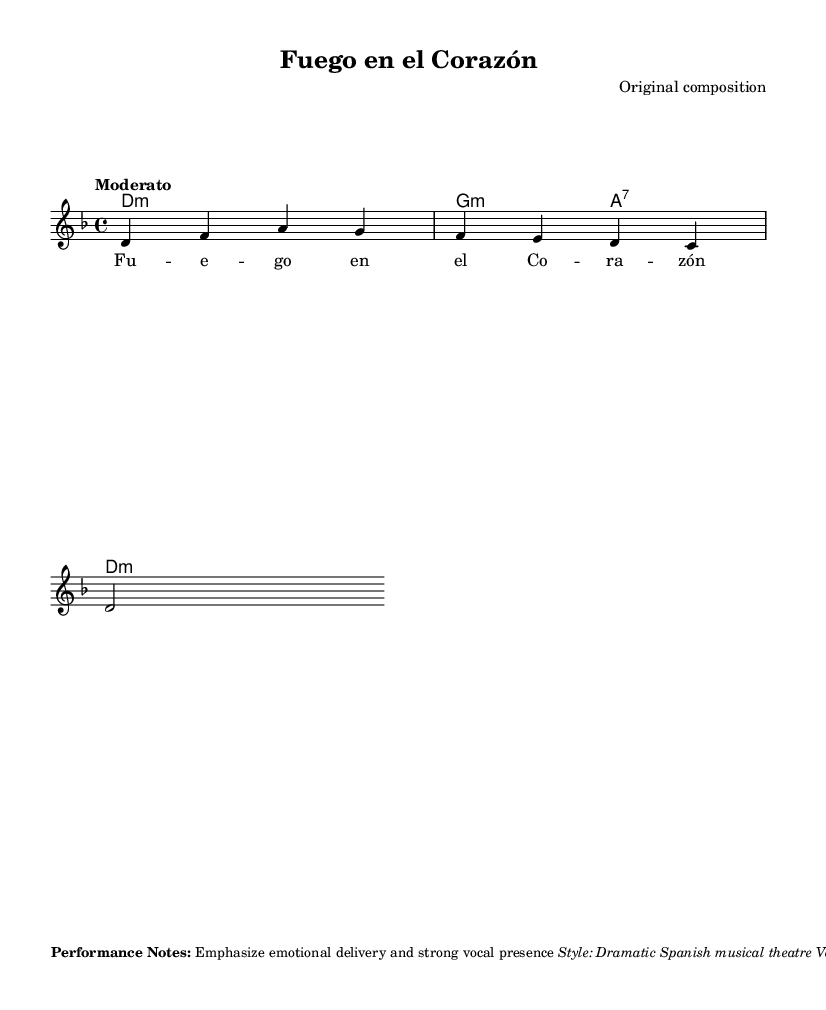What is the key signature of this music? The key signature is D minor, indicated by one flat (B flat) in the score.
Answer: D minor What is the time signature of this music? The time signature is 4/4, which means there are four beats in each measure, as shown at the start of the score.
Answer: 4/4 What is the tempo marking for this piece? The tempo marking is "Moderato," indicating a moderate pace throughout the piece.
Answer: Moderato What vocal range is specified for this piece? The vocal range specified is Mezzo-soprano, as noted in the performance notes, highlighting the required singing range.
Answer: Mezzo-soprano What is the main focus for vocal performance? The main focus for vocal performance is emotional delivery, as emphasized in the performance notes.
Answer: Emotional delivery How many measures are in the melody section? There are three measures in the melody section, confirmed by counting the bars indicated in the score.
Answer: Three measures What type of musical style is this piece categorized under? The musical style is categorized as Dramatic Spanish musical theatre, as identified in the performance notes.
Answer: Dramatic Spanish musical theatre 